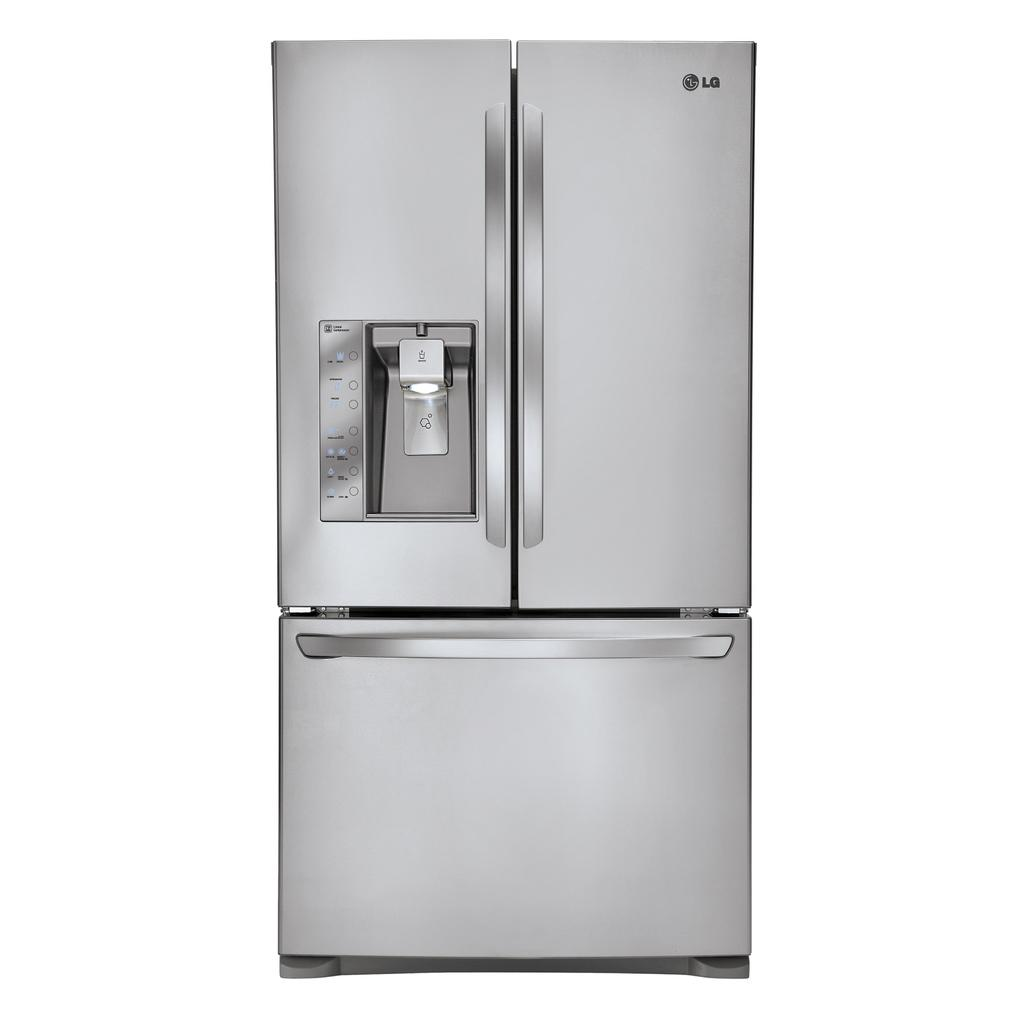<image>
Create a compact narrative representing the image presented. a fridge with LG written in the top right 